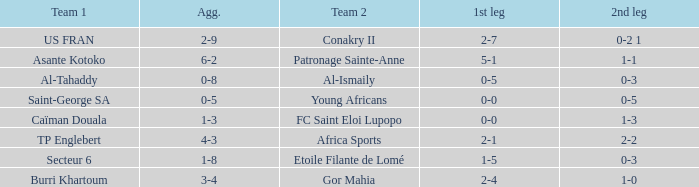Which teams had an aggregate score of 3-4? Burri Khartoum. 